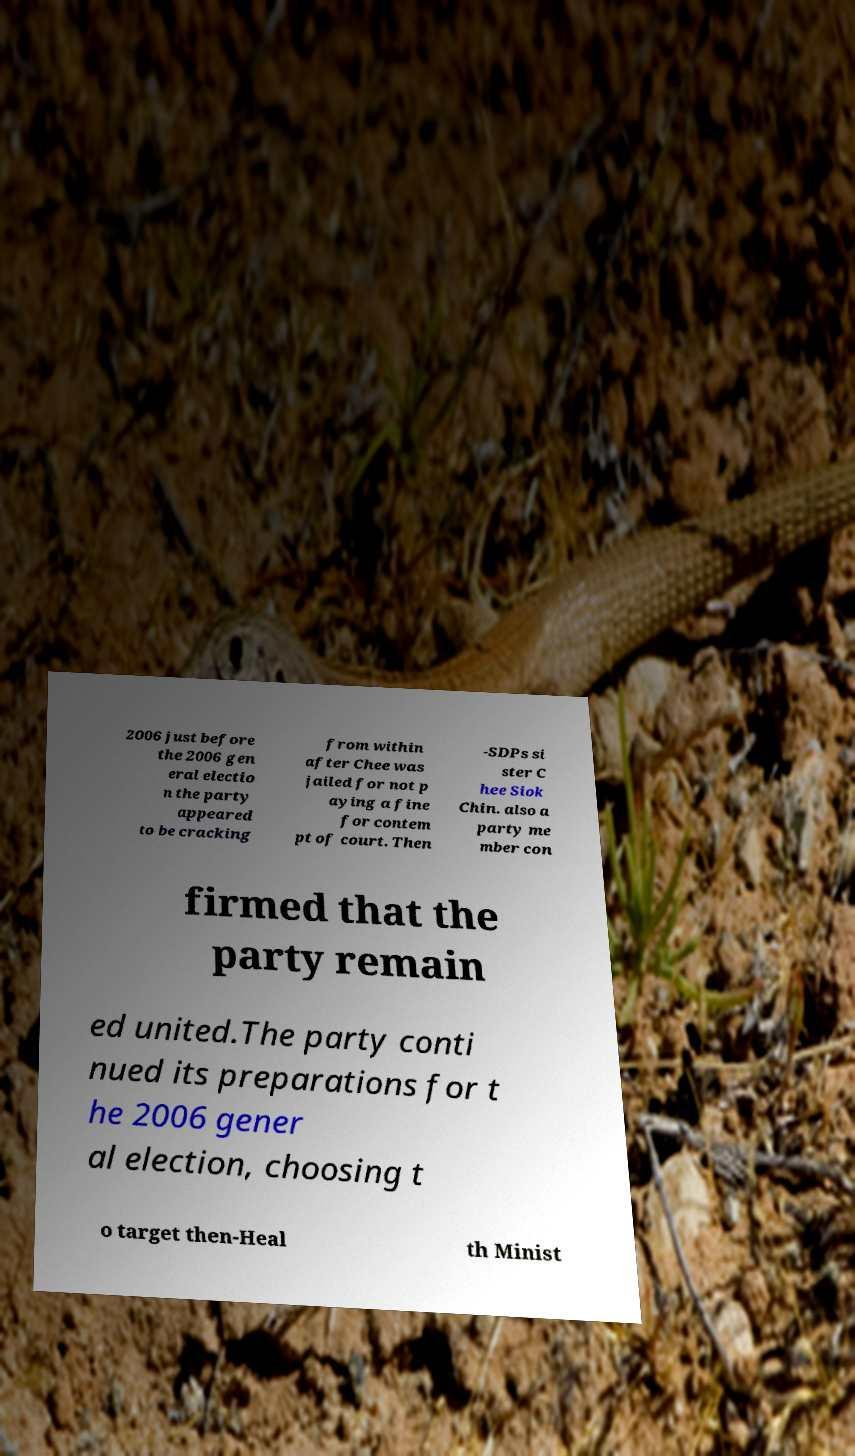Please read and relay the text visible in this image. What does it say? 2006 just before the 2006 gen eral electio n the party appeared to be cracking from within after Chee was jailed for not p aying a fine for contem pt of court. Then -SDPs si ster C hee Siok Chin. also a party me mber con firmed that the party remain ed united.The party conti nued its preparations for t he 2006 gener al election, choosing t o target then-Heal th Minist 